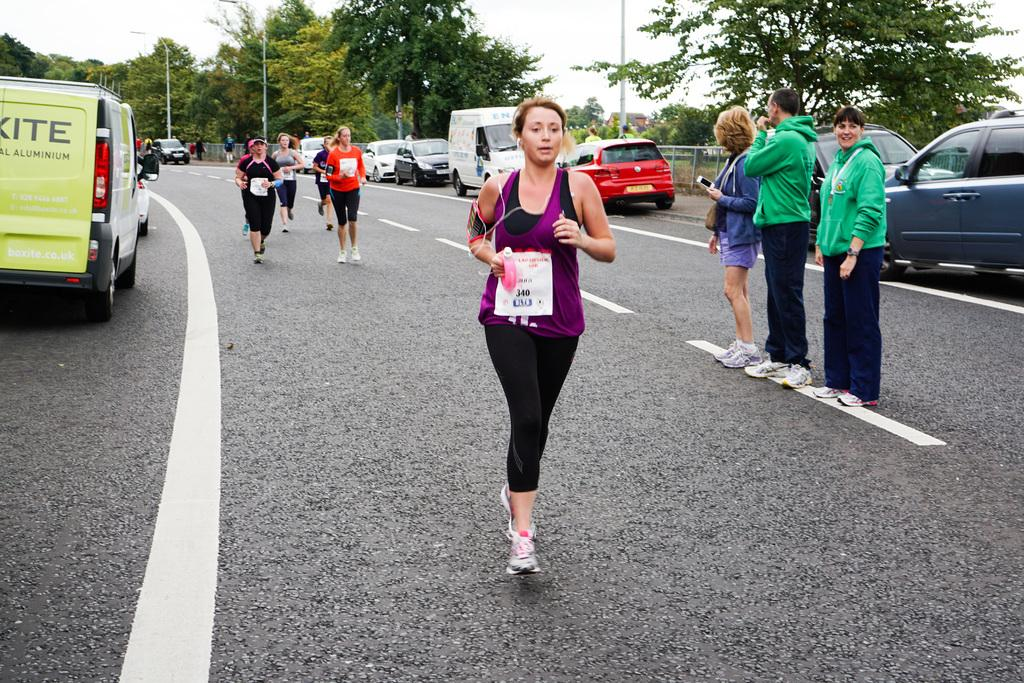<image>
Offer a succinct explanation of the picture presented. A woman wearing purple races down the road with the numbers 340 on her race bib 